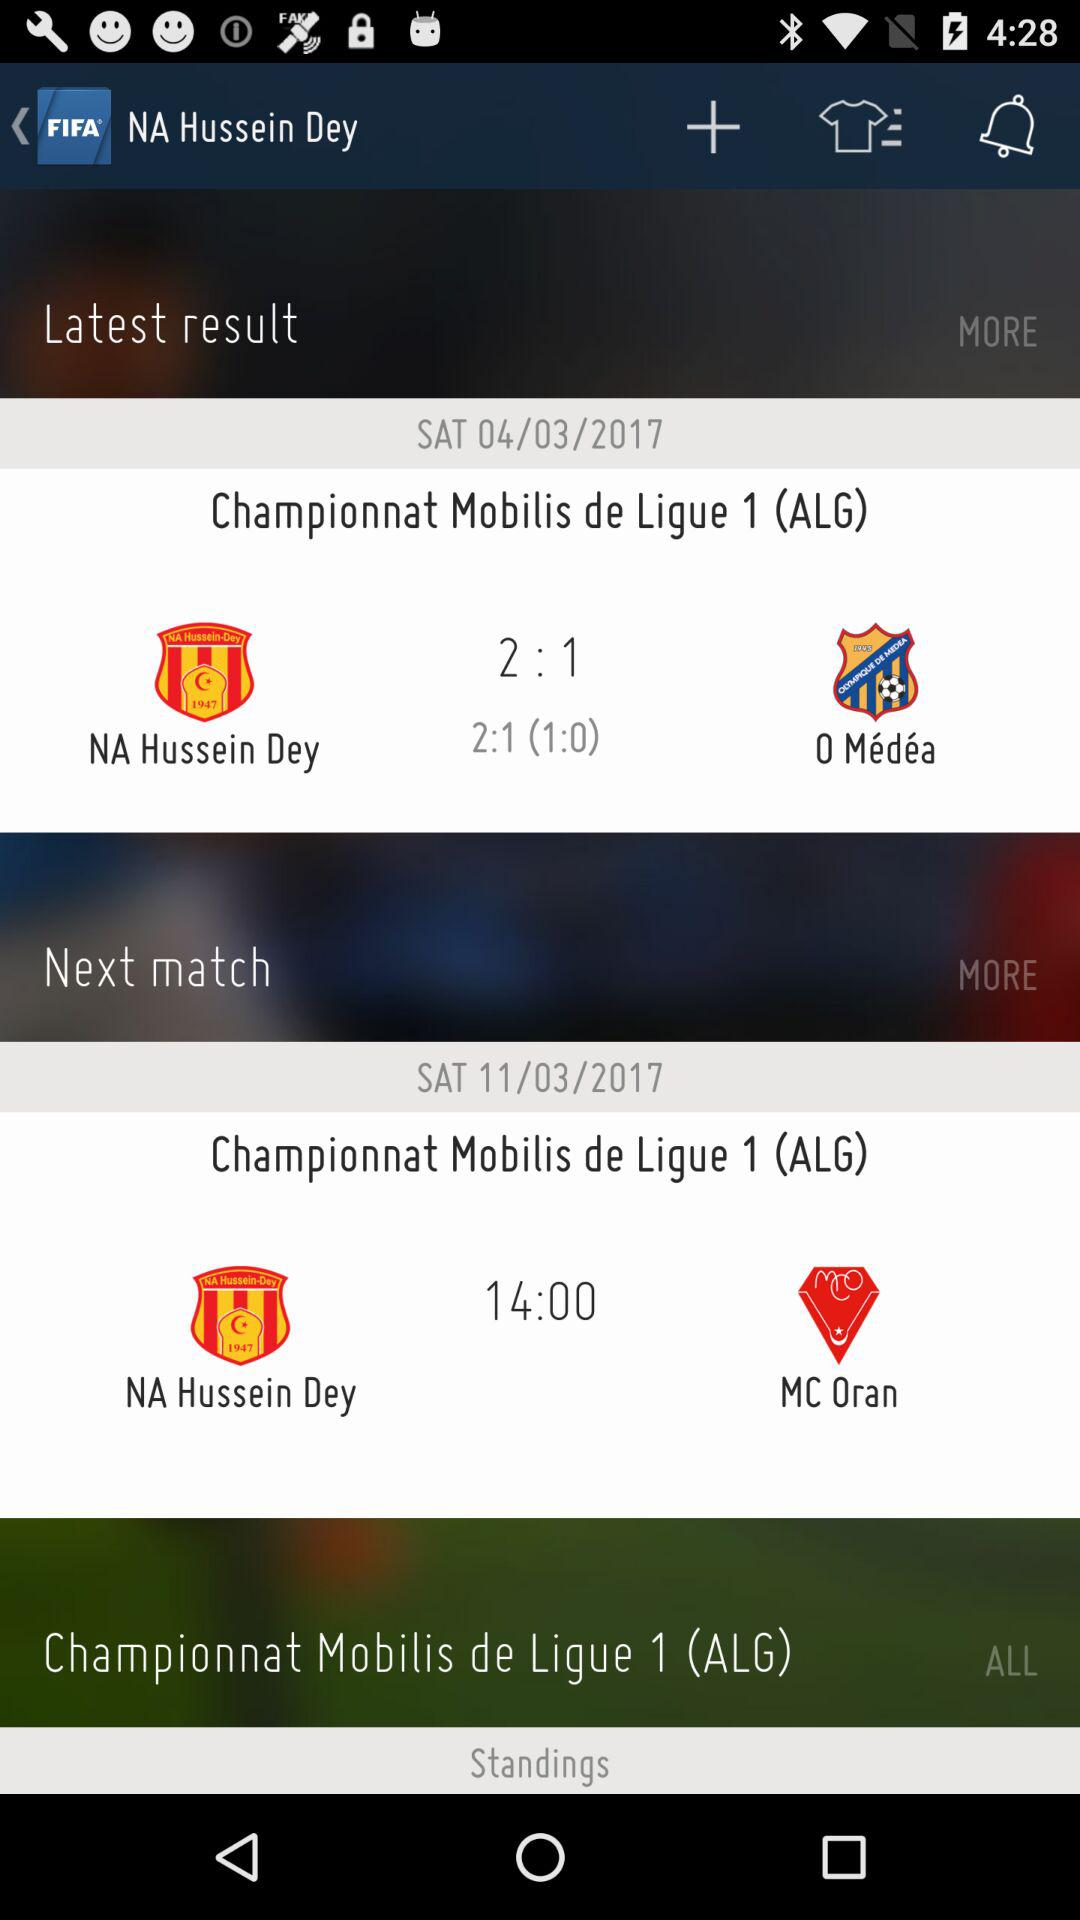At what time will the match between "NA Hussein Dey" and "MC Oran" start? The match between "NA Hussein Dey" and "MC Oran" will start at 14:00. 